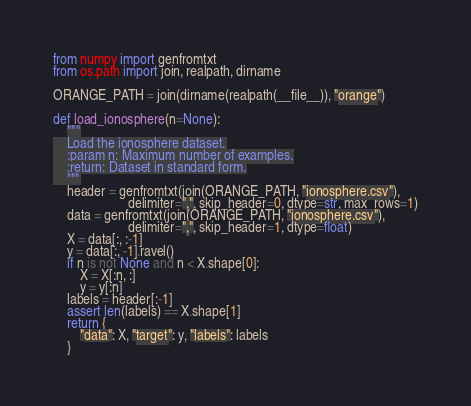Convert code to text. <code><loc_0><loc_0><loc_500><loc_500><_Python_>from numpy import genfromtxt
from os.path import join, realpath, dirname

ORANGE_PATH = join(dirname(realpath(__file__)), "orange")

def load_ionosphere(n=None):
    """
    Load the ionosphere dataset.
    :param n: Maximum number of examples.
    :return: Dataset in standard form.
    """
    header = genfromtxt(join(ORANGE_PATH, "ionosphere.csv"),
                      delimiter=",", skip_header=0, dtype=str, max_rows=1)
    data = genfromtxt(join(ORANGE_PATH, "ionosphere.csv"),
                      delimiter=",", skip_header=1, dtype=float)
    X = data[:, :-1]
    y = data[:, -1].ravel()
    if n is not None and n < X.shape[0]:
        X = X[:n, :]
        y = y[:n]
    labels = header[:-1]
    assert len(labels) == X.shape[1]
    return {
        "data": X, "target": y, "labels": labels
    }</code> 